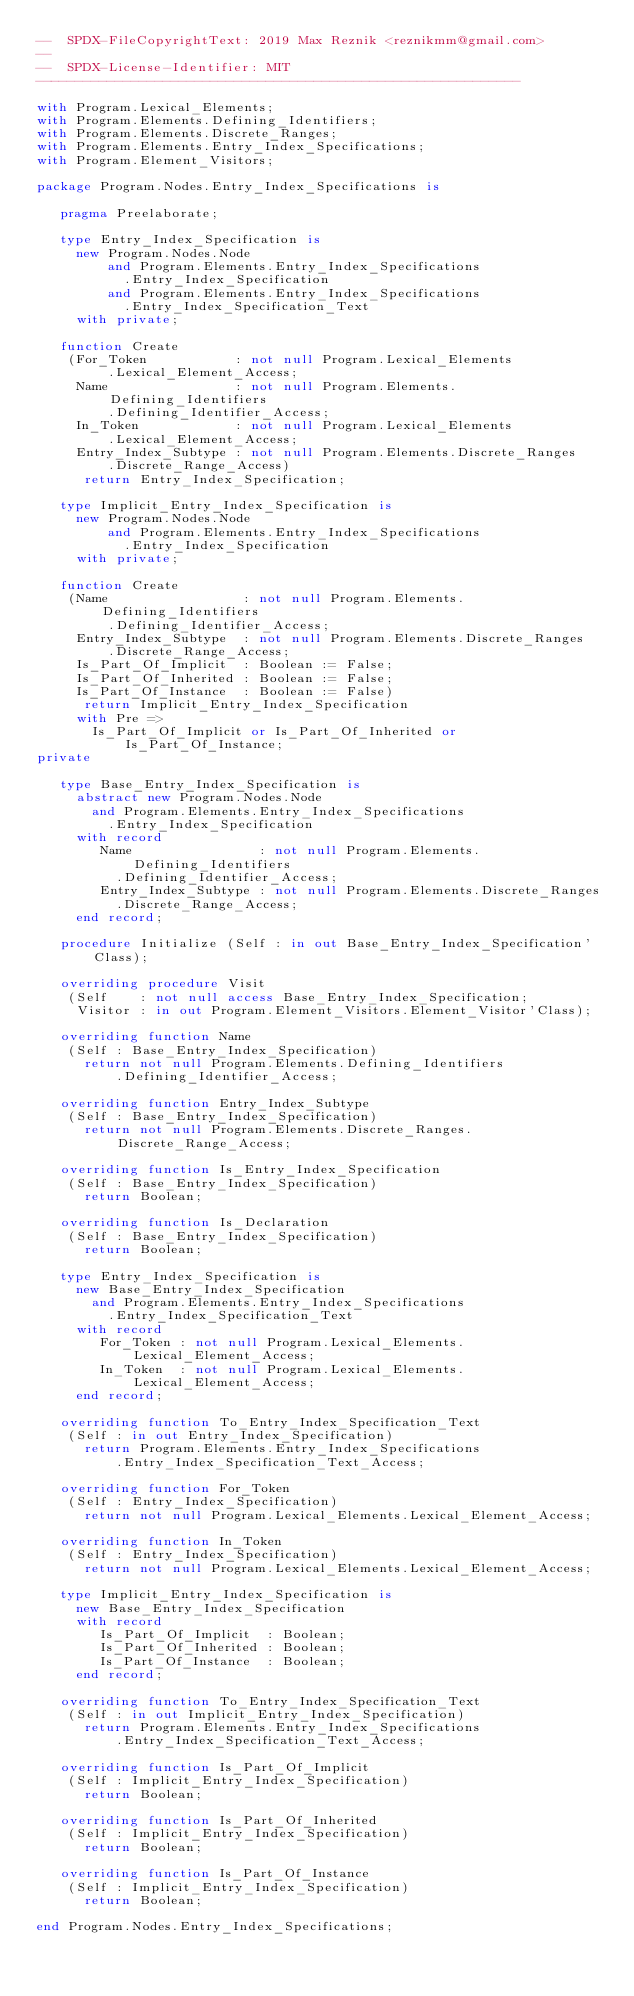Convert code to text. <code><loc_0><loc_0><loc_500><loc_500><_Ada_>--  SPDX-FileCopyrightText: 2019 Max Reznik <reznikmm@gmail.com>
--
--  SPDX-License-Identifier: MIT
-------------------------------------------------------------

with Program.Lexical_Elements;
with Program.Elements.Defining_Identifiers;
with Program.Elements.Discrete_Ranges;
with Program.Elements.Entry_Index_Specifications;
with Program.Element_Visitors;

package Program.Nodes.Entry_Index_Specifications is

   pragma Preelaborate;

   type Entry_Index_Specification is
     new Program.Nodes.Node
         and Program.Elements.Entry_Index_Specifications
           .Entry_Index_Specification
         and Program.Elements.Entry_Index_Specifications
           .Entry_Index_Specification_Text
     with private;

   function Create
    (For_Token           : not null Program.Lexical_Elements
         .Lexical_Element_Access;
     Name                : not null Program.Elements.Defining_Identifiers
         .Defining_Identifier_Access;
     In_Token            : not null Program.Lexical_Elements
         .Lexical_Element_Access;
     Entry_Index_Subtype : not null Program.Elements.Discrete_Ranges
         .Discrete_Range_Access)
      return Entry_Index_Specification;

   type Implicit_Entry_Index_Specification is
     new Program.Nodes.Node
         and Program.Elements.Entry_Index_Specifications
           .Entry_Index_Specification
     with private;

   function Create
    (Name                 : not null Program.Elements.Defining_Identifiers
         .Defining_Identifier_Access;
     Entry_Index_Subtype  : not null Program.Elements.Discrete_Ranges
         .Discrete_Range_Access;
     Is_Part_Of_Implicit  : Boolean := False;
     Is_Part_Of_Inherited : Boolean := False;
     Is_Part_Of_Instance  : Boolean := False)
      return Implicit_Entry_Index_Specification
     with Pre =>
       Is_Part_Of_Implicit or Is_Part_Of_Inherited or Is_Part_Of_Instance;
private

   type Base_Entry_Index_Specification is
     abstract new Program.Nodes.Node
       and Program.Elements.Entry_Index_Specifications
         .Entry_Index_Specification
     with record
        Name                : not null Program.Elements.Defining_Identifiers
          .Defining_Identifier_Access;
        Entry_Index_Subtype : not null Program.Elements.Discrete_Ranges
          .Discrete_Range_Access;
     end record;

   procedure Initialize (Self : in out Base_Entry_Index_Specification'Class);

   overriding procedure Visit
    (Self    : not null access Base_Entry_Index_Specification;
     Visitor : in out Program.Element_Visitors.Element_Visitor'Class);

   overriding function Name
    (Self : Base_Entry_Index_Specification)
      return not null Program.Elements.Defining_Identifiers
          .Defining_Identifier_Access;

   overriding function Entry_Index_Subtype
    (Self : Base_Entry_Index_Specification)
      return not null Program.Elements.Discrete_Ranges.Discrete_Range_Access;

   overriding function Is_Entry_Index_Specification
    (Self : Base_Entry_Index_Specification)
      return Boolean;

   overriding function Is_Declaration
    (Self : Base_Entry_Index_Specification)
      return Boolean;

   type Entry_Index_Specification is
     new Base_Entry_Index_Specification
       and Program.Elements.Entry_Index_Specifications
         .Entry_Index_Specification_Text
     with record
        For_Token : not null Program.Lexical_Elements.Lexical_Element_Access;
        In_Token  : not null Program.Lexical_Elements.Lexical_Element_Access;
     end record;

   overriding function To_Entry_Index_Specification_Text
    (Self : in out Entry_Index_Specification)
      return Program.Elements.Entry_Index_Specifications
          .Entry_Index_Specification_Text_Access;

   overriding function For_Token
    (Self : Entry_Index_Specification)
      return not null Program.Lexical_Elements.Lexical_Element_Access;

   overriding function In_Token
    (Self : Entry_Index_Specification)
      return not null Program.Lexical_Elements.Lexical_Element_Access;

   type Implicit_Entry_Index_Specification is
     new Base_Entry_Index_Specification
     with record
        Is_Part_Of_Implicit  : Boolean;
        Is_Part_Of_Inherited : Boolean;
        Is_Part_Of_Instance  : Boolean;
     end record;

   overriding function To_Entry_Index_Specification_Text
    (Self : in out Implicit_Entry_Index_Specification)
      return Program.Elements.Entry_Index_Specifications
          .Entry_Index_Specification_Text_Access;

   overriding function Is_Part_Of_Implicit
    (Self : Implicit_Entry_Index_Specification)
      return Boolean;

   overriding function Is_Part_Of_Inherited
    (Self : Implicit_Entry_Index_Specification)
      return Boolean;

   overriding function Is_Part_Of_Instance
    (Self : Implicit_Entry_Index_Specification)
      return Boolean;

end Program.Nodes.Entry_Index_Specifications;
</code> 